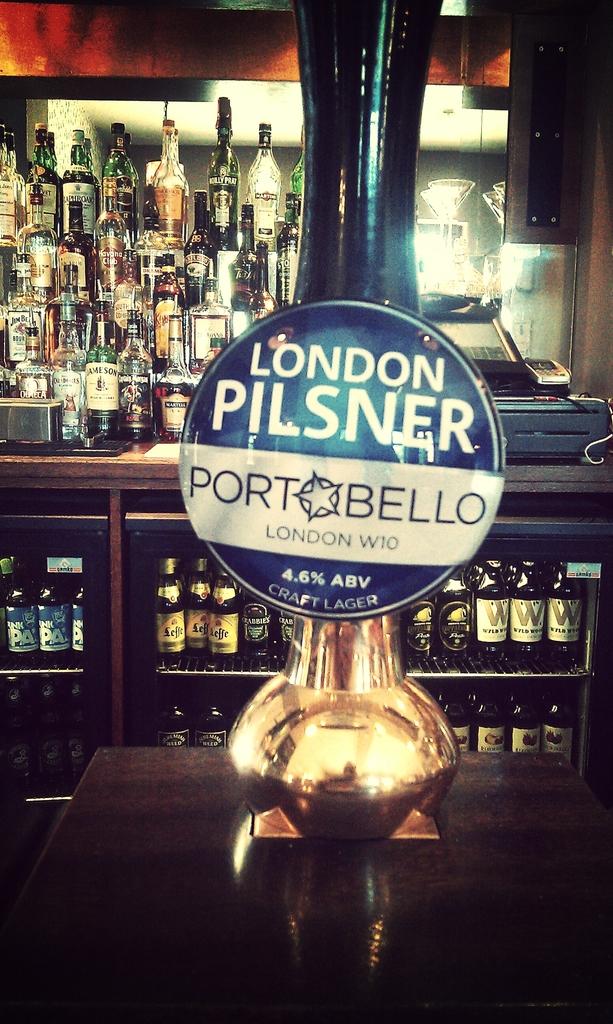What city is this pilsner from?
Ensure brevity in your answer.  London. 